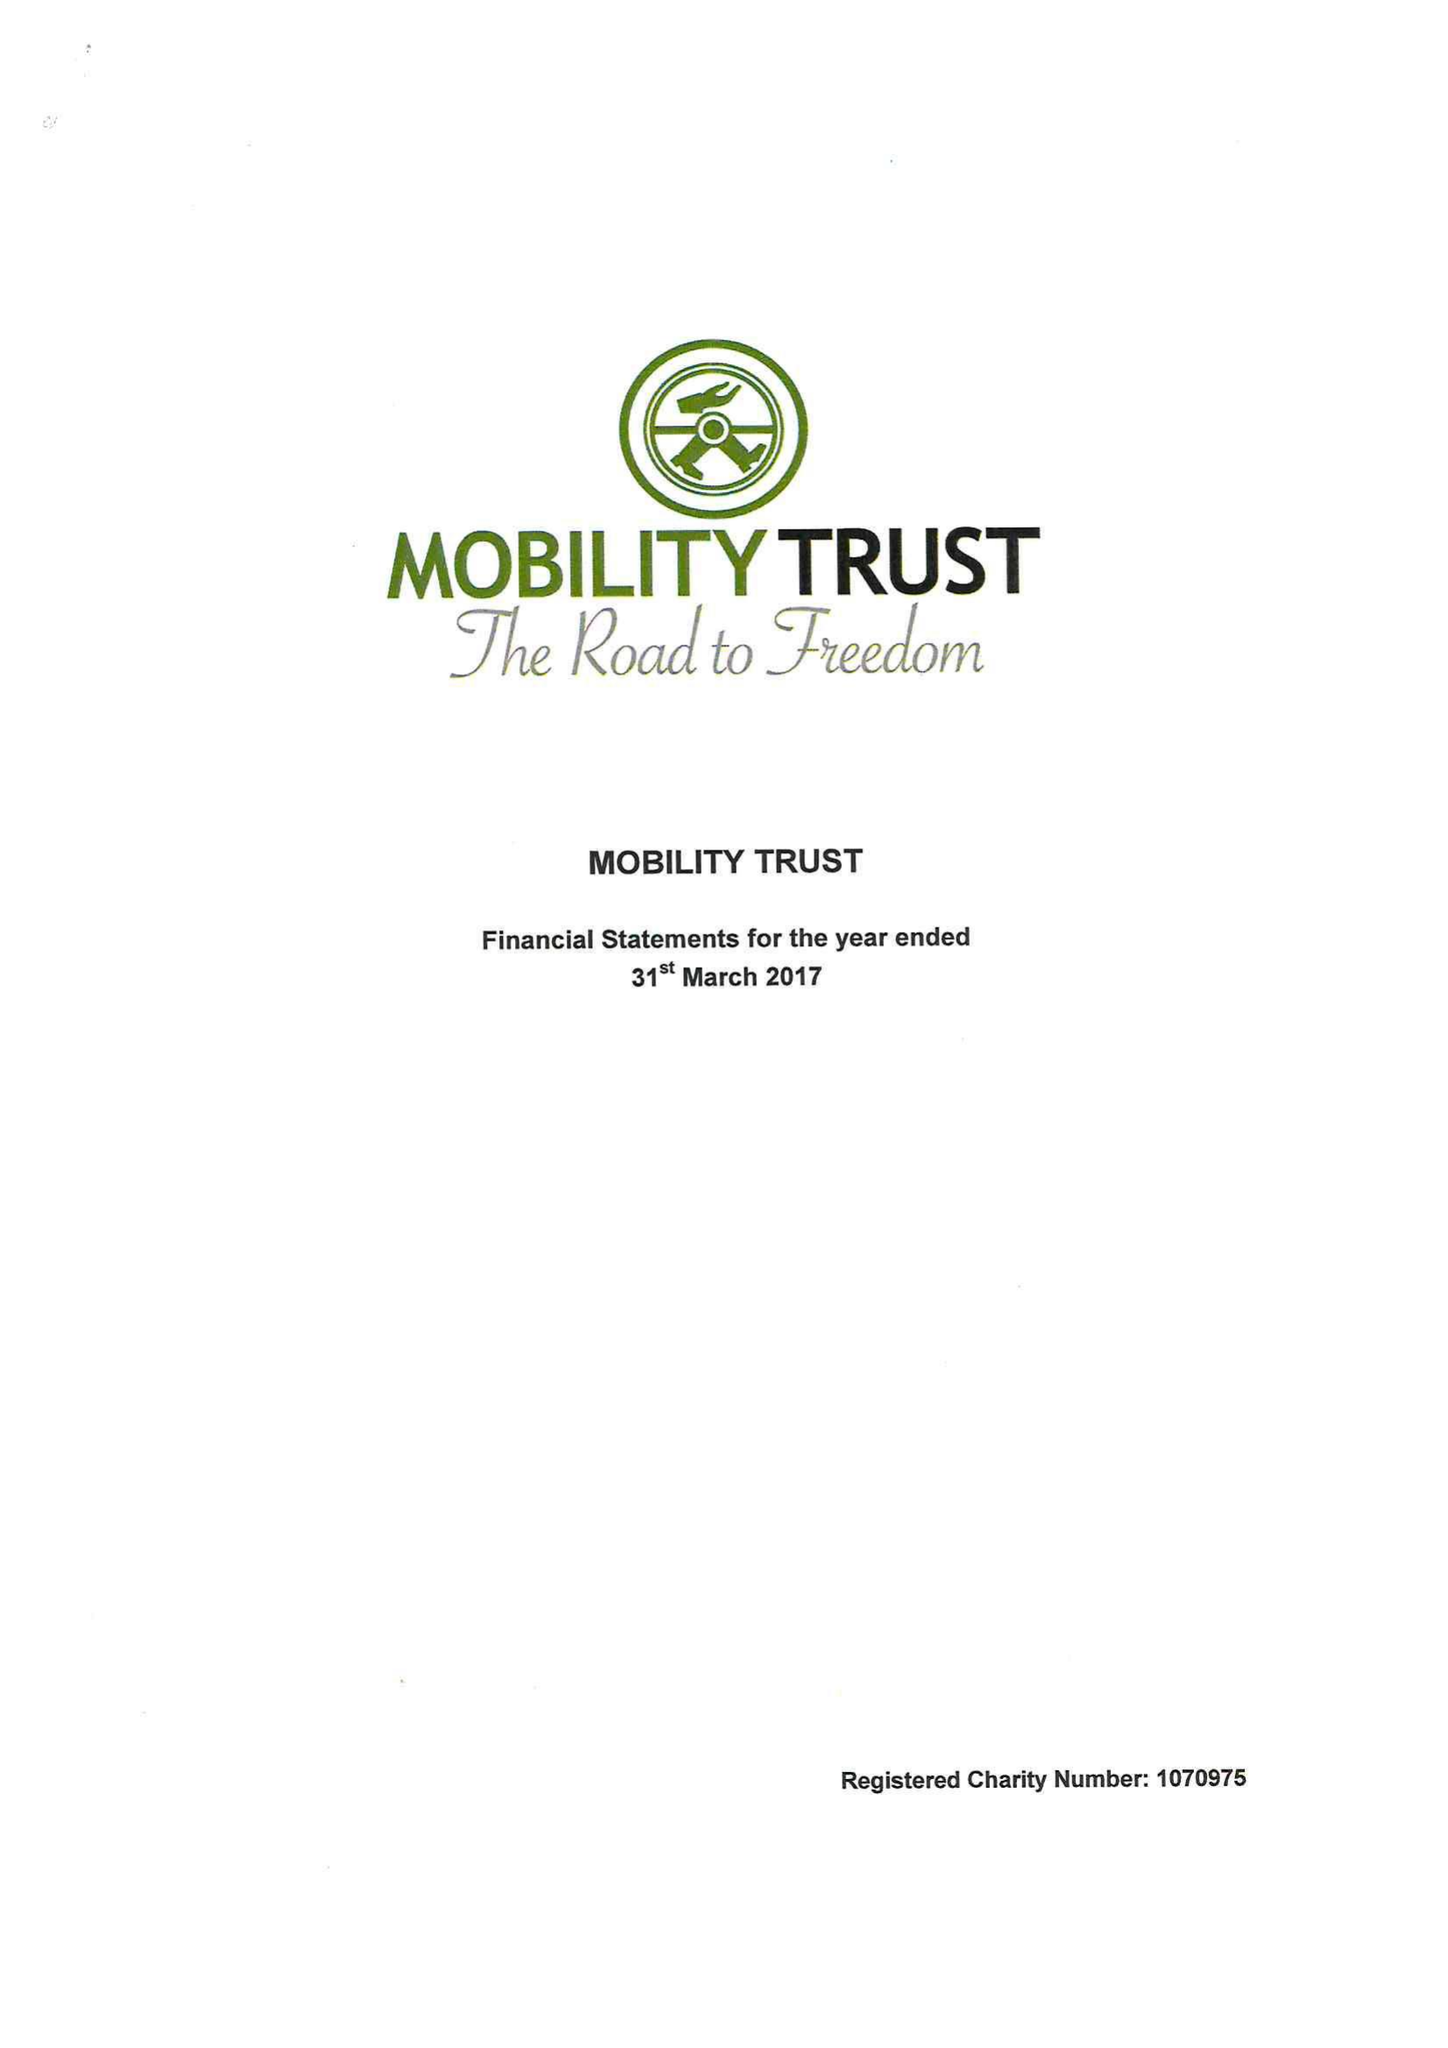What is the value for the address__post_town?
Answer the question using a single word or phrase. READING 